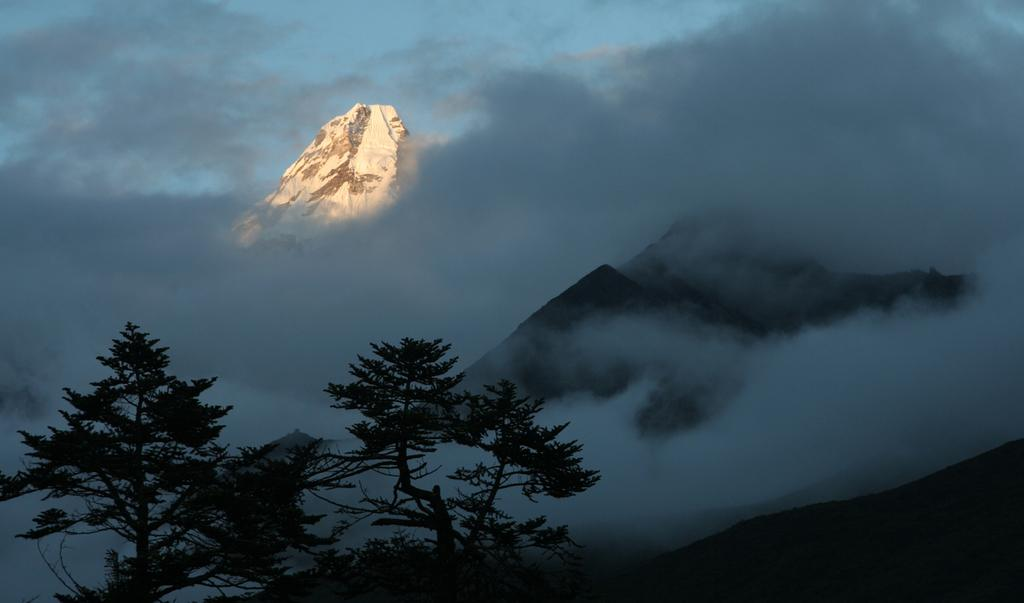What type of natural landforms can be seen in the image? There are mountains and hills in the image. What type of vegetation is present in the image? There are trees in the image. What is visible in the sky in the image? The sky is visible in the image, and there are clouds in the sky. What type of insect can be seen crawling on the stove in the image? There is no stove or insect present in the image. 